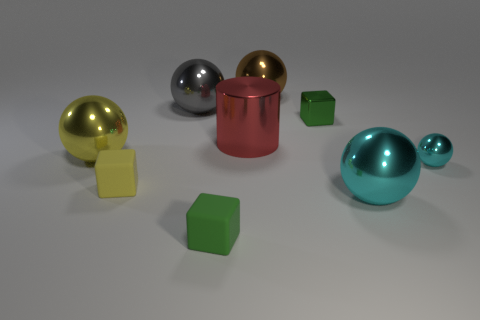Are there any other small blocks that have the same color as the small metal cube?
Offer a terse response. Yes. What size is the thing that is the same color as the small shiny ball?
Your answer should be compact. Large. Is there a small purple block made of the same material as the gray object?
Offer a very short reply. No. Are there an equal number of shiny balls that are behind the small metallic sphere and cyan shiny objects that are behind the big brown shiny thing?
Provide a short and direct response. No. How big is the yellow shiny ball in front of the brown metallic thing?
Offer a very short reply. Large. There is a green cube that is in front of the tiny green block that is on the right side of the large brown sphere; what is its material?
Provide a succinct answer. Rubber. What number of brown things are left of the big cyan metallic object that is on the right side of the small green metal thing that is on the left side of the small cyan metallic thing?
Ensure brevity in your answer.  1. Are the large thing that is behind the big gray object and the large ball that is on the left side of the big gray thing made of the same material?
Provide a succinct answer. Yes. What is the material of the tiny thing that is the same color as the metal block?
Your answer should be very brief. Rubber. What number of shiny things are the same shape as the tiny green rubber thing?
Provide a succinct answer. 1. 